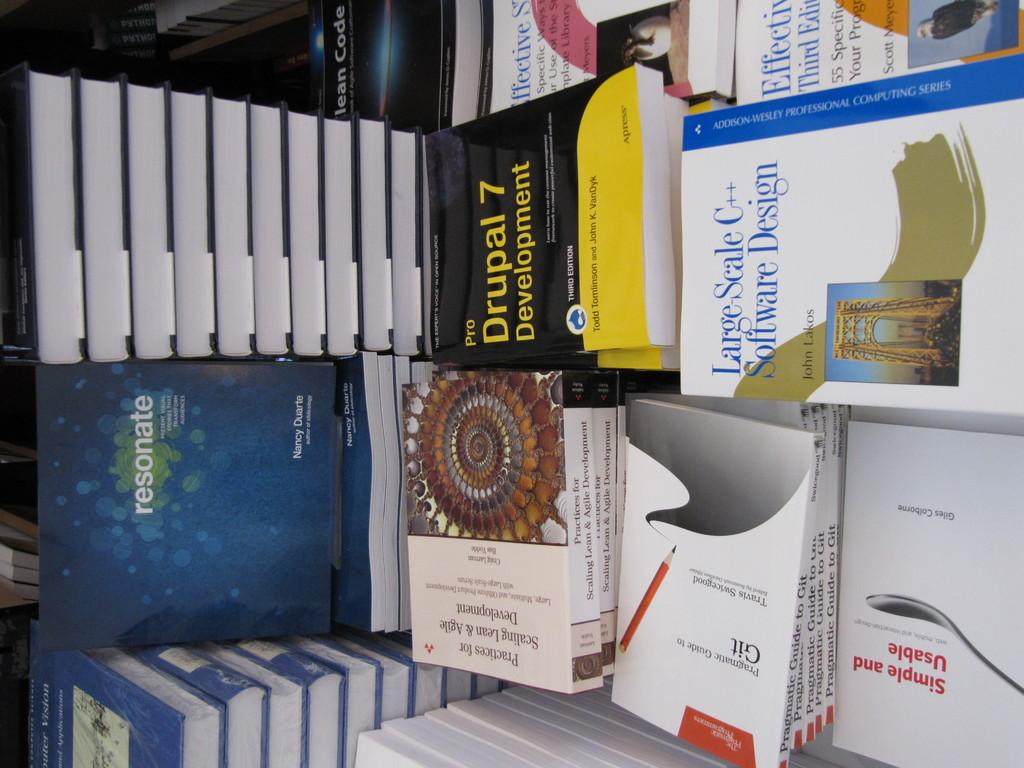What objects are present in the image? There is a group of books in the image. Where are the books located? The books are placed on a surface. What type of shade is provided by the moon in the image? There is no moon present in the image, and therefore no shade is provided by it. What type of competition is taking place between the books in the image? There is no competition between the books in the image, as they are simply a group of objects placed on a surface. 